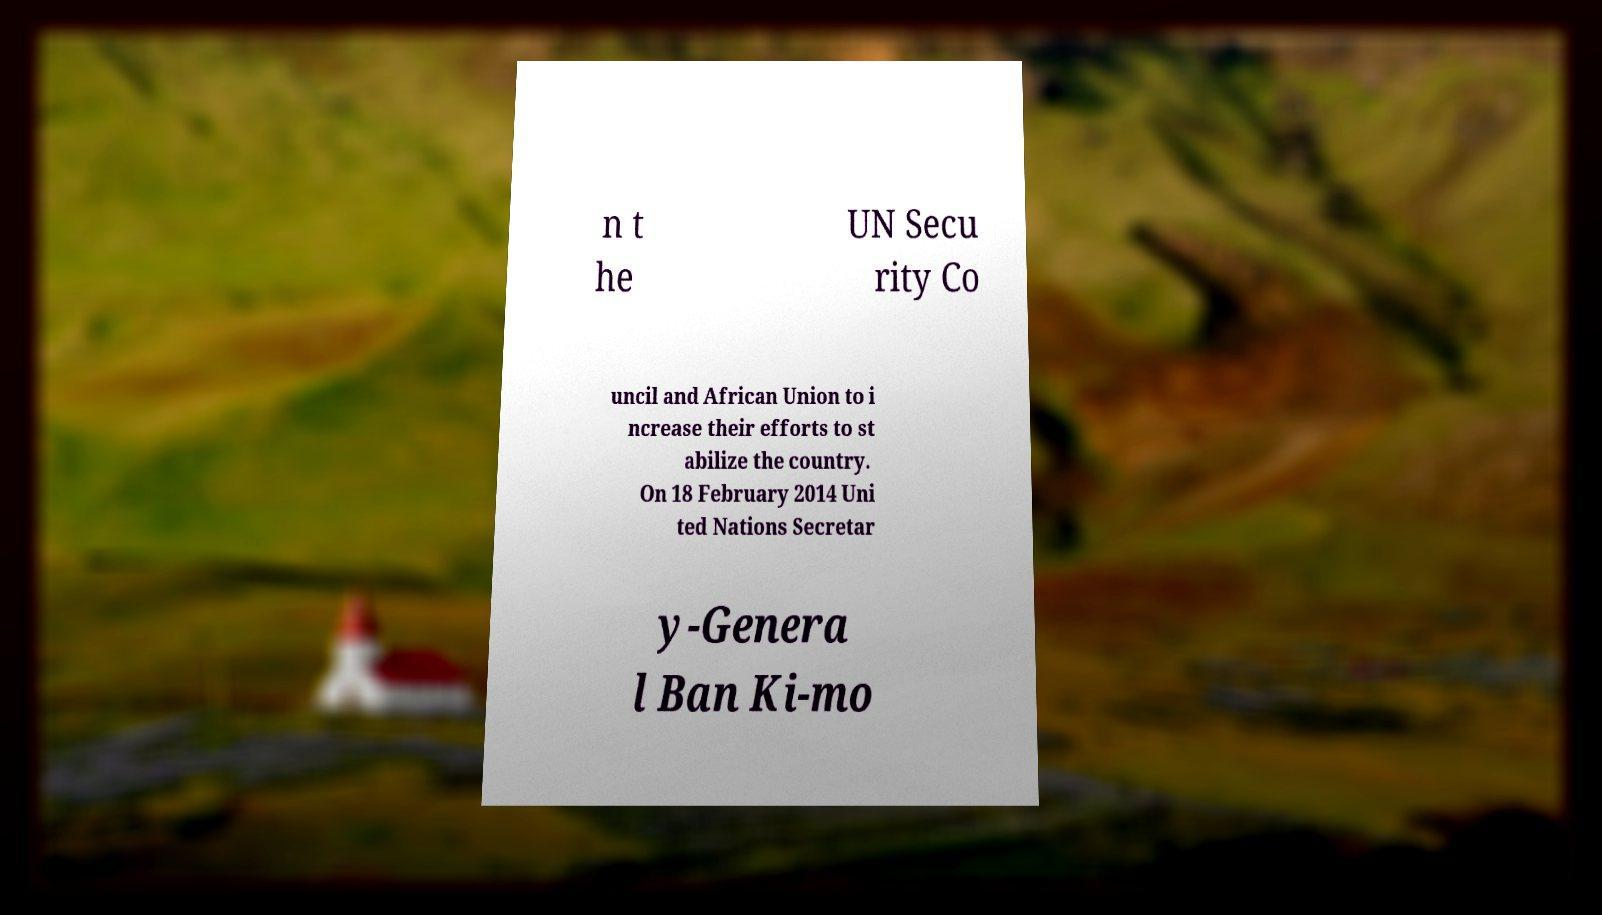Could you assist in decoding the text presented in this image and type it out clearly? n t he UN Secu rity Co uncil and African Union to i ncrease their efforts to st abilize the country. On 18 February 2014 Uni ted Nations Secretar y-Genera l Ban Ki-mo 